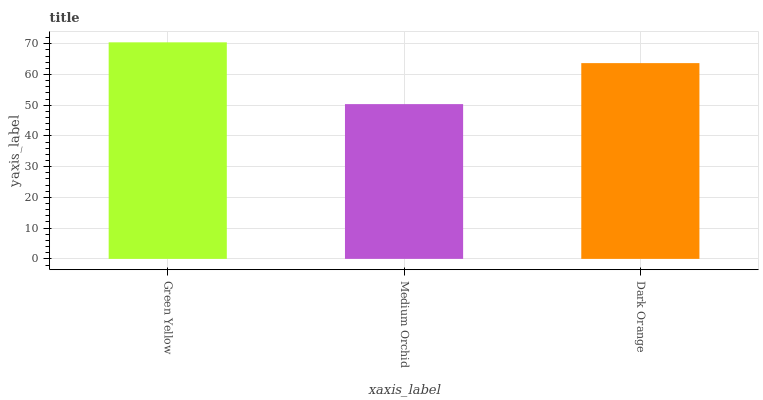Is Medium Orchid the minimum?
Answer yes or no. Yes. Is Green Yellow the maximum?
Answer yes or no. Yes. Is Dark Orange the minimum?
Answer yes or no. No. Is Dark Orange the maximum?
Answer yes or no. No. Is Dark Orange greater than Medium Orchid?
Answer yes or no. Yes. Is Medium Orchid less than Dark Orange?
Answer yes or no. Yes. Is Medium Orchid greater than Dark Orange?
Answer yes or no. No. Is Dark Orange less than Medium Orchid?
Answer yes or no. No. Is Dark Orange the high median?
Answer yes or no. Yes. Is Dark Orange the low median?
Answer yes or no. Yes. Is Green Yellow the high median?
Answer yes or no. No. Is Medium Orchid the low median?
Answer yes or no. No. 